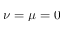Convert formula to latex. <formula><loc_0><loc_0><loc_500><loc_500>\nu = \mu = 0</formula> 